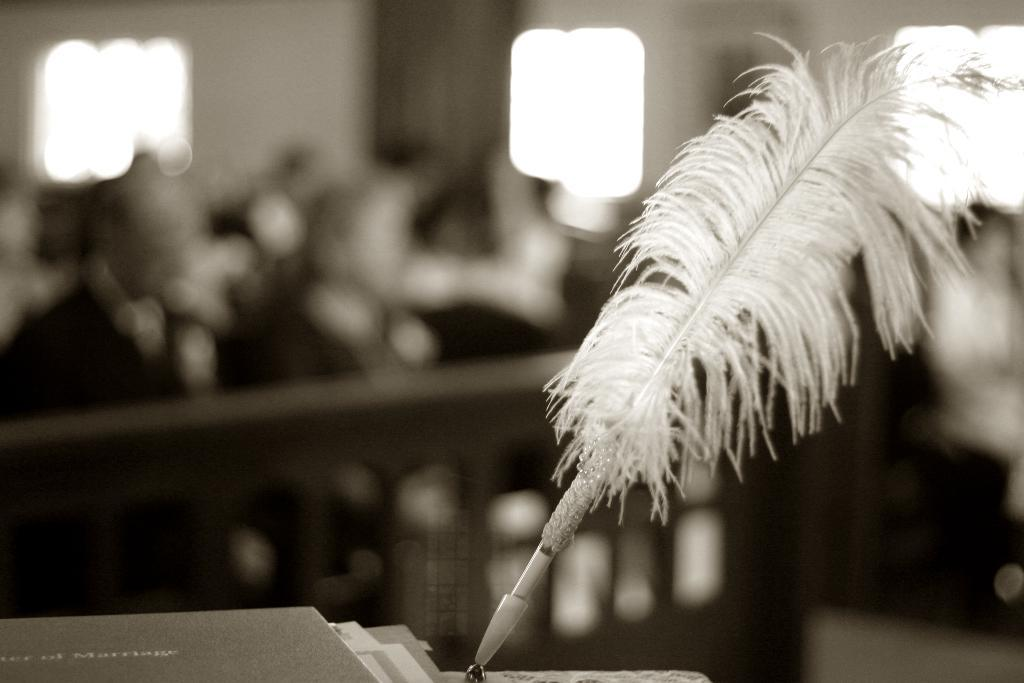What writing instrument is in the foreground of the image? There is a feather pen in the foreground of the image. What other objects are near the feather pen? There are books beside the feather pen. Can you describe the background of the image? The background of the image is blurred. What type of drain is visible in the image? There is no drain present in the image. 